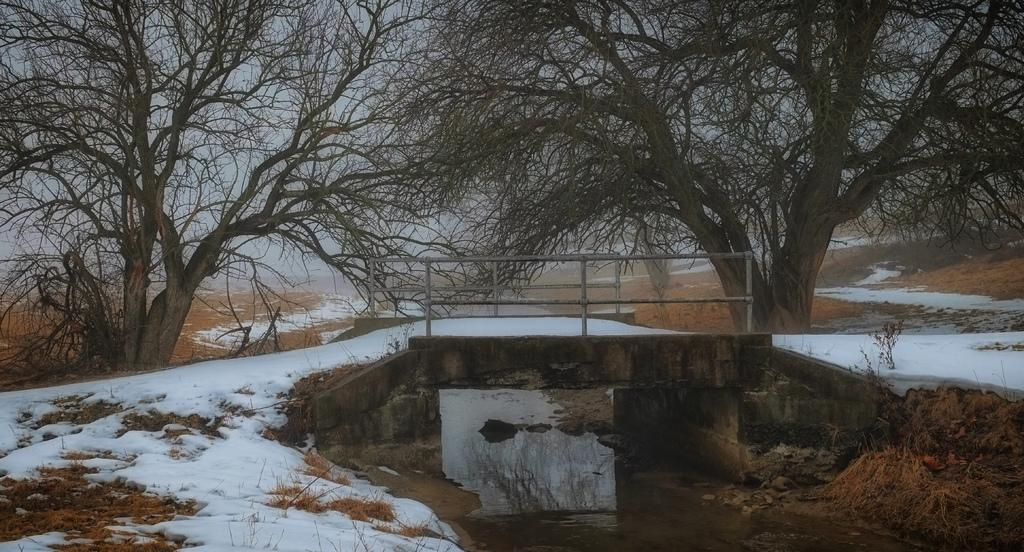What type of weather is depicted in the image? There is snow in the image, indicating cold weather. What else can be seen in the image besides snow? There is water, plants, a bridge, trees, and the sky visible in the image. Can you describe the vegetation in the image? There are plants and trees in the image. What is the background of the image? The sky is visible in the background of the image. What word is written in the snow in the image? There are no words written in the snow in the image. Can you see a rake being used to clear the snow in the image? There is no rake present in the image. 